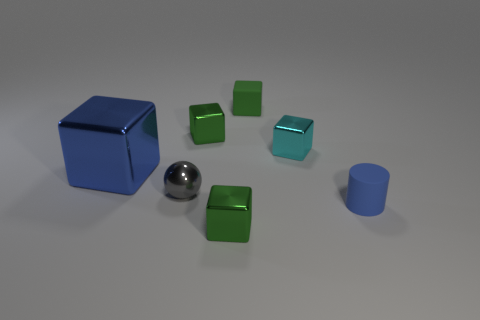How many green blocks must be subtracted to get 1 green blocks? 2 Subtract all brown spheres. How many green cubes are left? 3 Subtract all cyan blocks. How many blocks are left? 4 Subtract all large cubes. How many cubes are left? 4 Add 3 blue objects. How many objects exist? 10 Subtract all blue cubes. Subtract all purple cylinders. How many cubes are left? 4 Subtract all blocks. How many objects are left? 2 Add 7 large matte cylinders. How many large matte cylinders exist? 7 Subtract 0 yellow cubes. How many objects are left? 7 Subtract all gray things. Subtract all large metallic cubes. How many objects are left? 5 